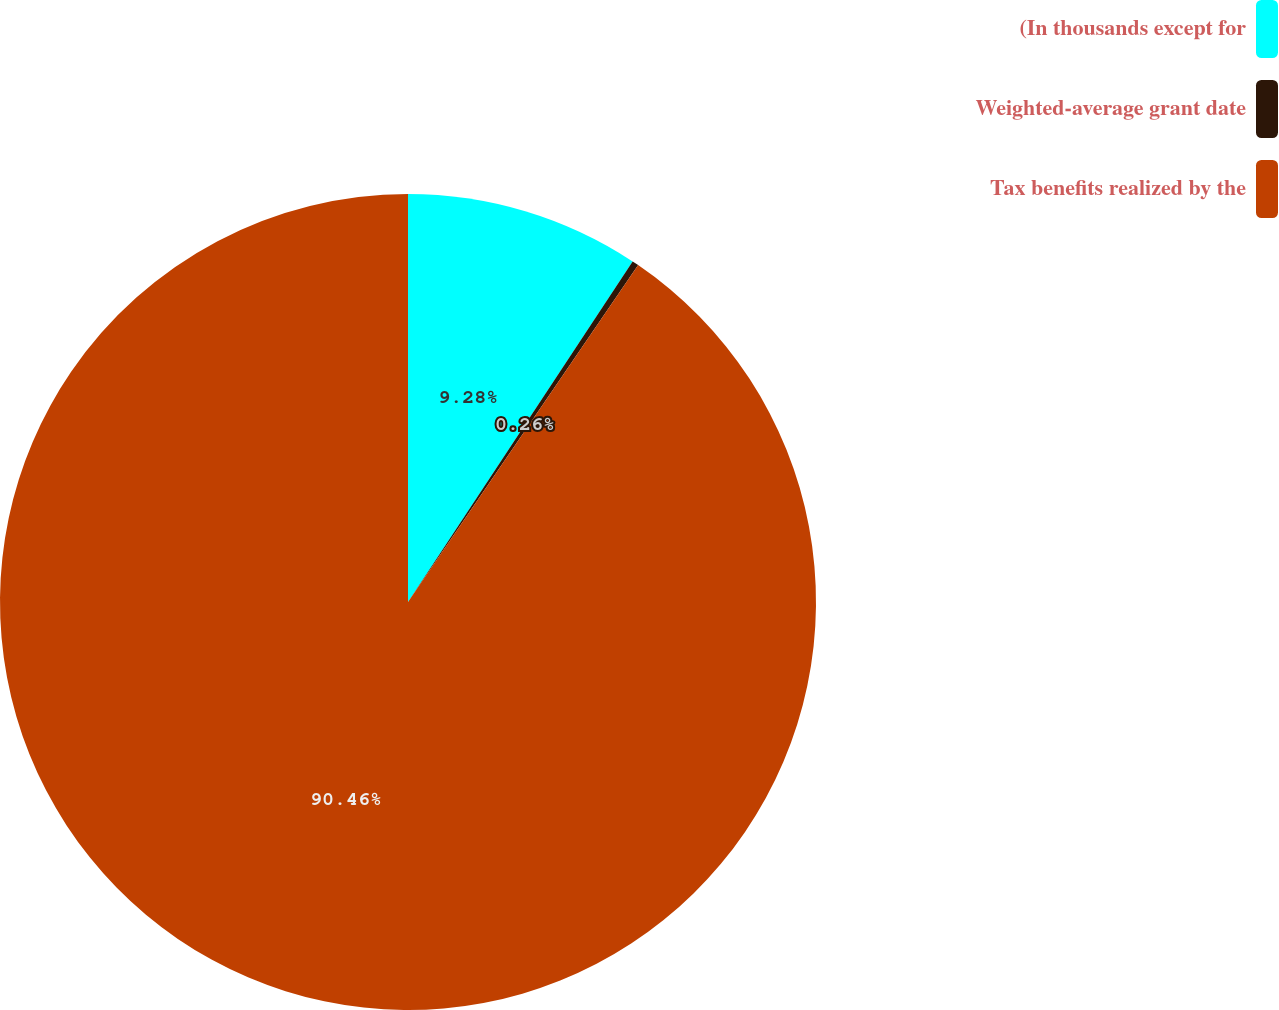<chart> <loc_0><loc_0><loc_500><loc_500><pie_chart><fcel>(In thousands except for<fcel>Weighted-average grant date<fcel>Tax benefits realized by the<nl><fcel>9.28%<fcel>0.26%<fcel>90.47%<nl></chart> 